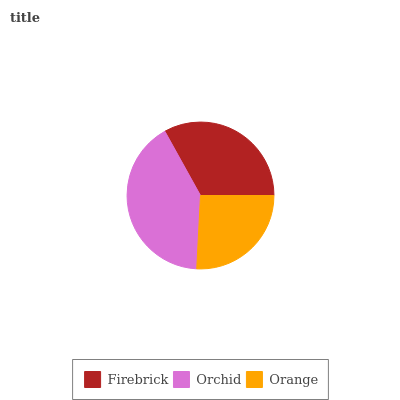Is Orange the minimum?
Answer yes or no. Yes. Is Orchid the maximum?
Answer yes or no. Yes. Is Orchid the minimum?
Answer yes or no. No. Is Orange the maximum?
Answer yes or no. No. Is Orchid greater than Orange?
Answer yes or no. Yes. Is Orange less than Orchid?
Answer yes or no. Yes. Is Orange greater than Orchid?
Answer yes or no. No. Is Orchid less than Orange?
Answer yes or no. No. Is Firebrick the high median?
Answer yes or no. Yes. Is Firebrick the low median?
Answer yes or no. Yes. Is Orchid the high median?
Answer yes or no. No. Is Orange the low median?
Answer yes or no. No. 